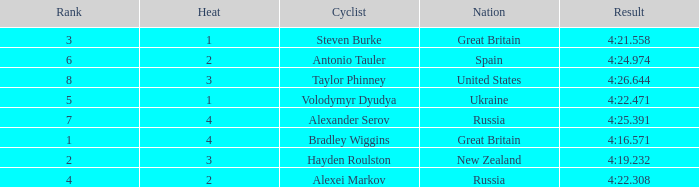What is the lowest rank that spain got? 6.0. 